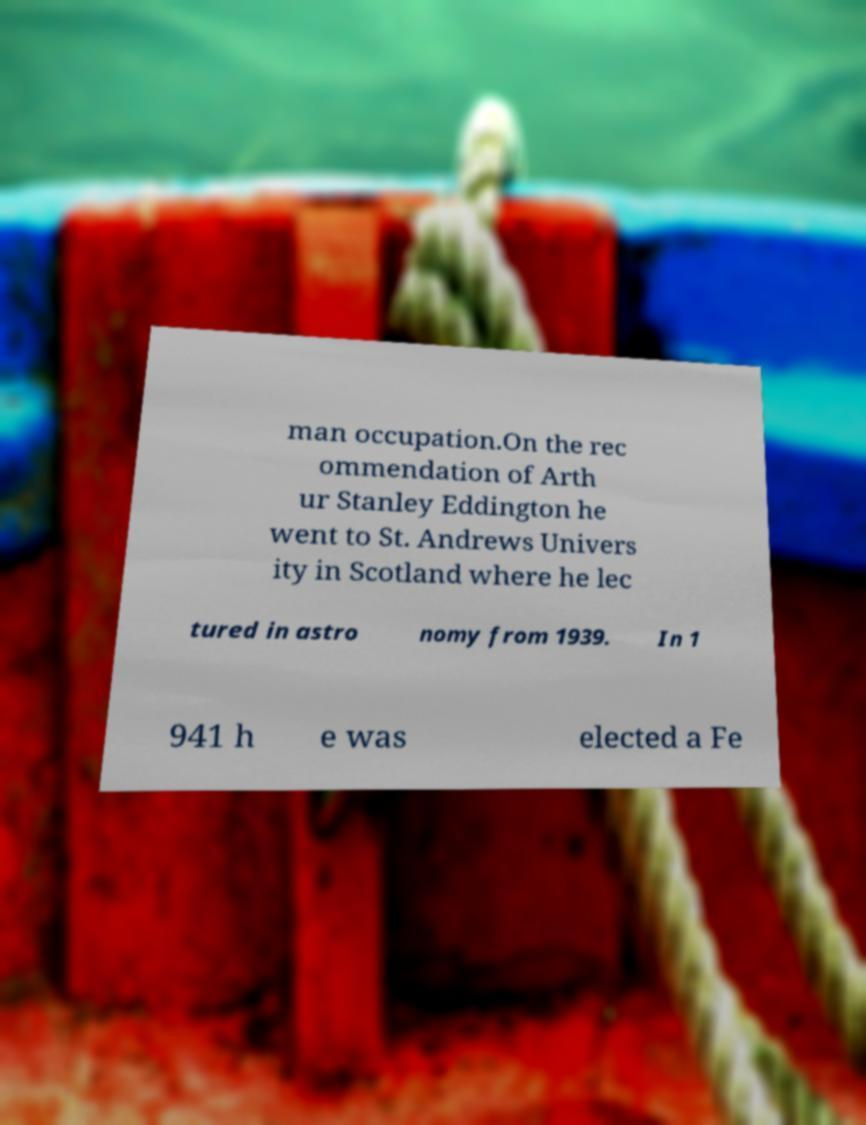Can you accurately transcribe the text from the provided image for me? man occupation.On the rec ommendation of Arth ur Stanley Eddington he went to St. Andrews Univers ity in Scotland where he lec tured in astro nomy from 1939. In 1 941 h e was elected a Fe 